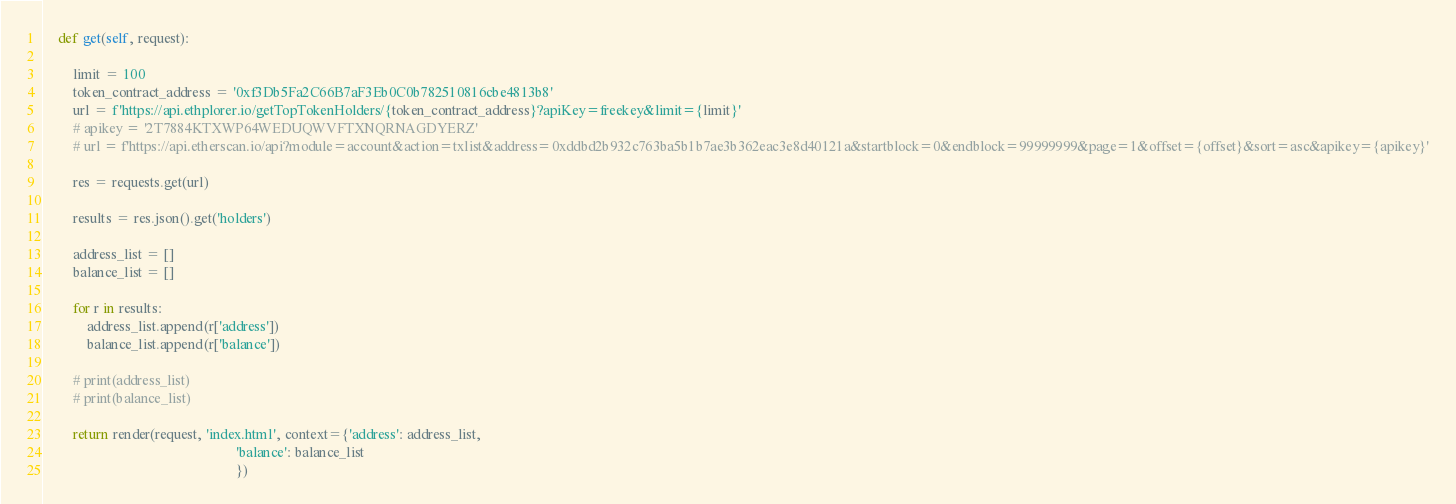Convert code to text. <code><loc_0><loc_0><loc_500><loc_500><_Python_>
    def get(self, request):

        limit = 100
        token_contract_address = '0xf3Db5Fa2C66B7aF3Eb0C0b782510816cbe4813b8'
        url = f'https://api.ethplorer.io/getTopTokenHolders/{token_contract_address}?apiKey=freekey&limit={limit}'
        # apikey = '2T7884KTXWP64WEDUQWVFTXNQRNAGDYERZ'
        # url = f'https://api.etherscan.io/api?module=account&action=txlist&address=0xddbd2b932c763ba5b1b7ae3b362eac3e8d40121a&startblock=0&endblock=99999999&page=1&offset={offset}&sort=asc&apikey={apikey}'

        res = requests.get(url)

        results = res.json().get('holders')

        address_list = []
        balance_list = []

        for r in results:
            address_list.append(r['address'])
            balance_list.append(r['balance'])

        # print(address_list)
        # print(balance_list)

        return render(request, 'index.html', context={'address': address_list,
                                                      'balance': balance_list
                                                      })
</code> 